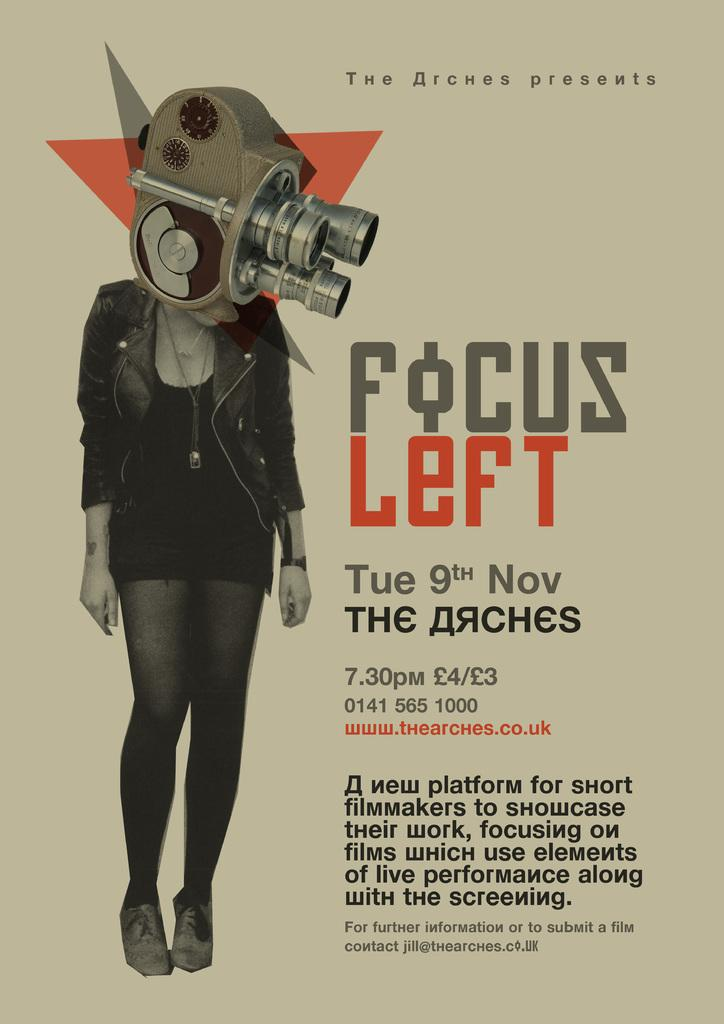Provide a one-sentence caption for the provided image. Poster showing a woman with a telescope head and the words "Focus Left". 